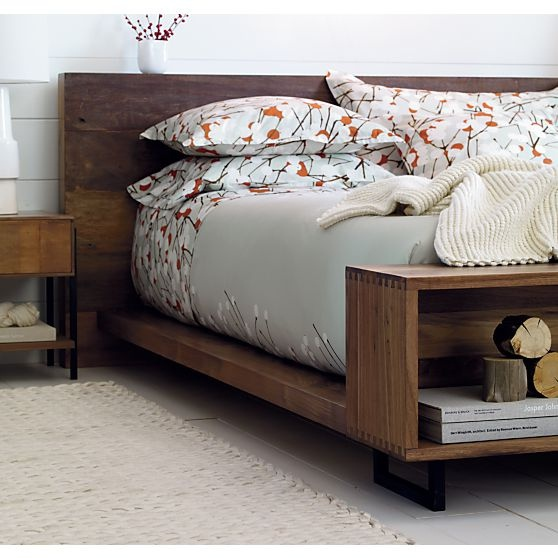Describe the objects in this image and their specific colors. I can see bed in white, black, lightgray, darkgray, and maroon tones and vase in white, lightgray, and darkgray tones in this image. 